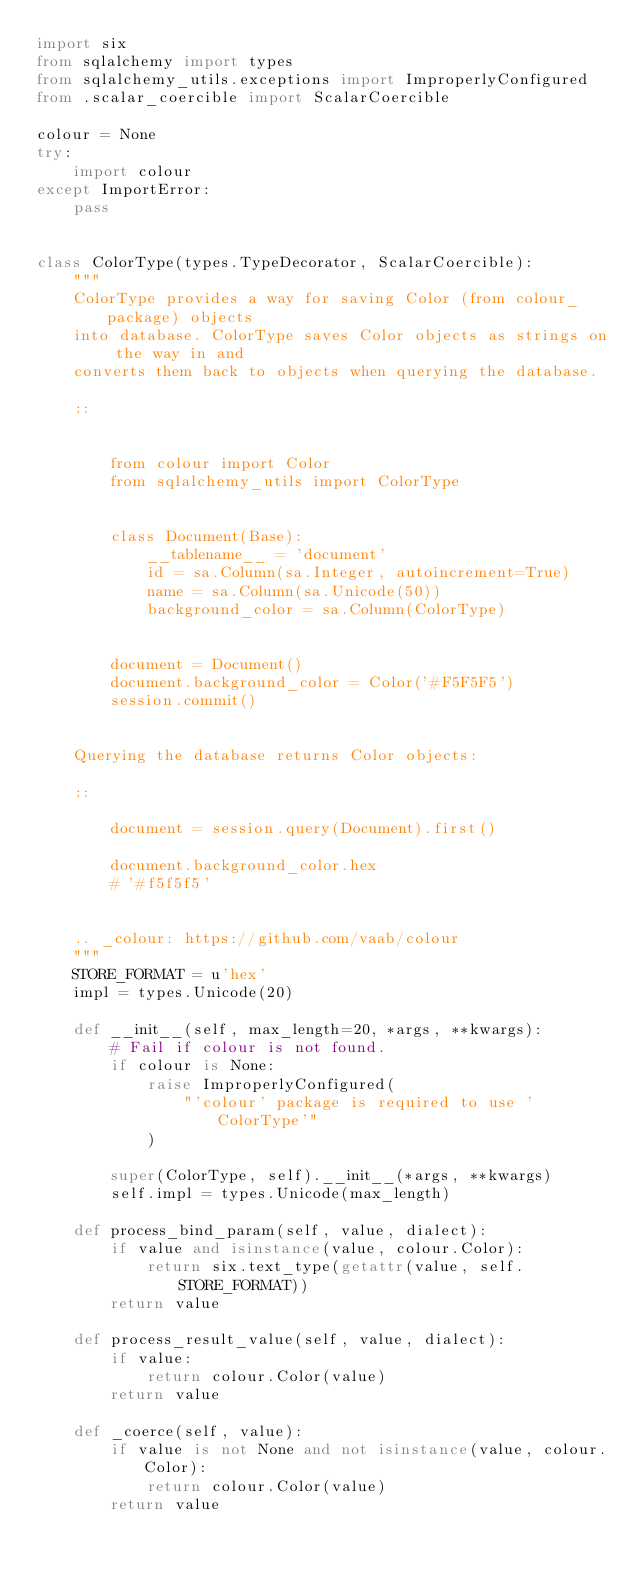<code> <loc_0><loc_0><loc_500><loc_500><_Python_>import six
from sqlalchemy import types
from sqlalchemy_utils.exceptions import ImproperlyConfigured
from .scalar_coercible import ScalarCoercible

colour = None
try:
    import colour
except ImportError:
    pass


class ColorType(types.TypeDecorator, ScalarCoercible):
    """
    ColorType provides a way for saving Color (from colour_ package) objects
    into database. ColorType saves Color objects as strings on the way in and
    converts them back to objects when querying the database.

    ::


        from colour import Color
        from sqlalchemy_utils import ColorType


        class Document(Base):
            __tablename__ = 'document'
            id = sa.Column(sa.Integer, autoincrement=True)
            name = sa.Column(sa.Unicode(50))
            background_color = sa.Column(ColorType)


        document = Document()
        document.background_color = Color('#F5F5F5')
        session.commit()


    Querying the database returns Color objects:

    ::

        document = session.query(Document).first()

        document.background_color.hex
        # '#f5f5f5'


    .. _colour: https://github.com/vaab/colour
    """
    STORE_FORMAT = u'hex'
    impl = types.Unicode(20)

    def __init__(self, max_length=20, *args, **kwargs):
        # Fail if colour is not found.
        if colour is None:
            raise ImproperlyConfigured(
                "'colour' package is required to use 'ColorType'"
            )

        super(ColorType, self).__init__(*args, **kwargs)
        self.impl = types.Unicode(max_length)

    def process_bind_param(self, value, dialect):
        if value and isinstance(value, colour.Color):
            return six.text_type(getattr(value, self.STORE_FORMAT))
        return value

    def process_result_value(self, value, dialect):
        if value:
            return colour.Color(value)
        return value

    def _coerce(self, value):
        if value is not None and not isinstance(value, colour.Color):
            return colour.Color(value)
        return value
</code> 